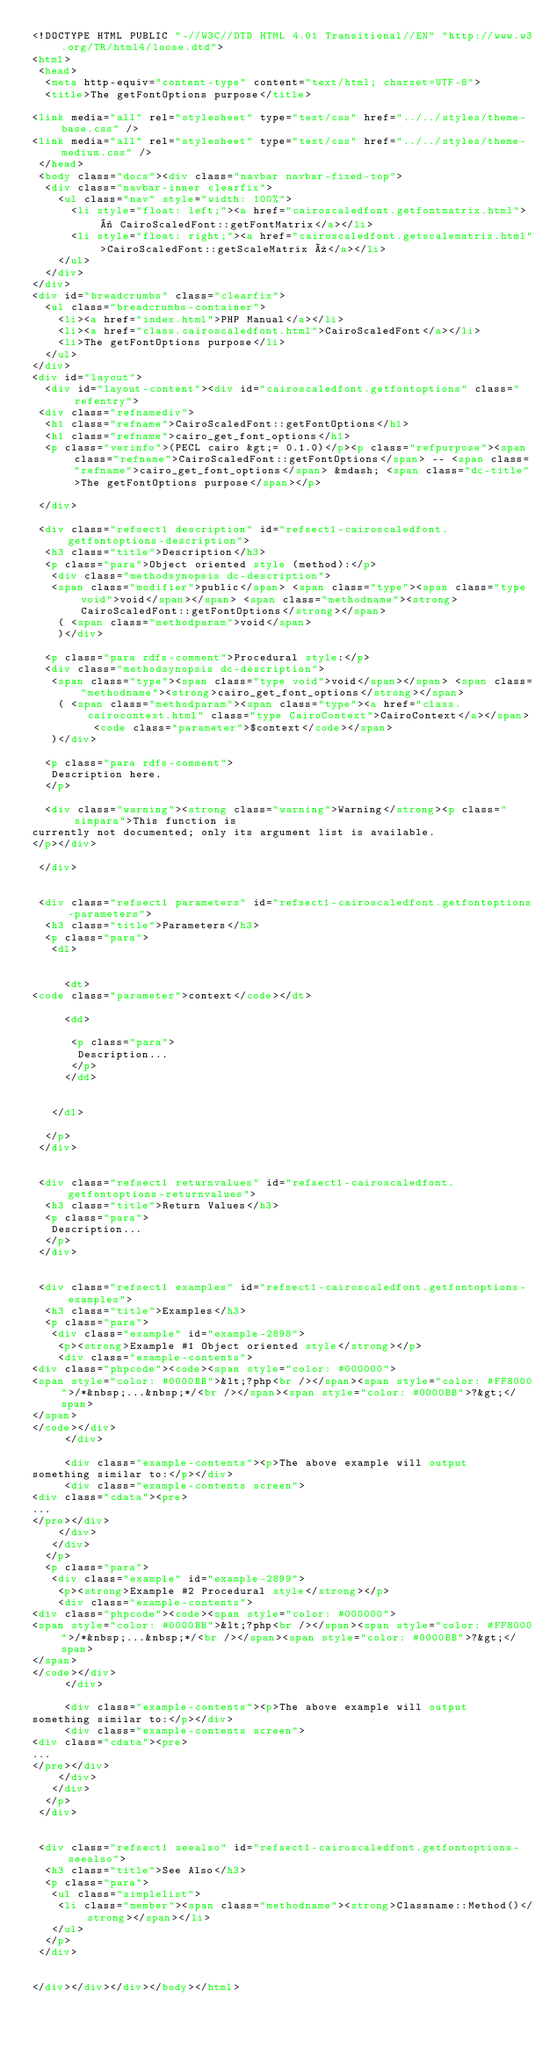<code> <loc_0><loc_0><loc_500><loc_500><_HTML_><!DOCTYPE HTML PUBLIC "-//W3C//DTD HTML 4.01 Transitional//EN" "http://www.w3.org/TR/html4/loose.dtd">
<html>
 <head>
  <meta http-equiv="content-type" content="text/html; charset=UTF-8">
  <title>The getFontOptions purpose</title>

<link media="all" rel="stylesheet" type="text/css" href="../../styles/theme-base.css" />
<link media="all" rel="stylesheet" type="text/css" href="../../styles/theme-medium.css" />
 </head>
 <body class="docs"><div class="navbar navbar-fixed-top">
  <div class="navbar-inner clearfix">
    <ul class="nav" style="width: 100%">
      <li style="float: left;"><a href="cairoscaledfont.getfontmatrix.html">« CairoScaledFont::getFontMatrix</a></li>
      <li style="float: right;"><a href="cairoscaledfont.getscalematrix.html">CairoScaledFont::getScaleMatrix »</a></li>
    </ul>
  </div>
</div>
<div id="breadcrumbs" class="clearfix">
  <ul class="breadcrumbs-container">
    <li><a href="index.html">PHP Manual</a></li>
    <li><a href="class.cairoscaledfont.html">CairoScaledFont</a></li>
    <li>The getFontOptions purpose</li>
  </ul>
</div>
<div id="layout">
  <div id="layout-content"><div id="cairoscaledfont.getfontoptions" class="refentry">
 <div class="refnamediv">
  <h1 class="refname">CairoScaledFont::getFontOptions</h1>
  <h1 class="refname">cairo_get_font_options</h1>
  <p class="verinfo">(PECL cairo &gt;= 0.1.0)</p><p class="refpurpose"><span class="refname">CairoScaledFont::getFontOptions</span> -- <span class="refname">cairo_get_font_options</span> &mdash; <span class="dc-title">The getFontOptions purpose</span></p>

 </div>

 <div class="refsect1 description" id="refsect1-cairoscaledfont.getfontoptions-description">
  <h3 class="title">Description</h3>
  <p class="para">Object oriented style (method):</p>
   <div class="methodsynopsis dc-description">
   <span class="modifier">public</span> <span class="type"><span class="type void">void</span></span> <span class="methodname"><strong>CairoScaledFont::getFontOptions</strong></span>
    ( <span class="methodparam">void</span>
    )</div>

  <p class="para rdfs-comment">Procedural style:</p>
  <div class="methodsynopsis dc-description">
   <span class="type"><span class="type void">void</span></span> <span class="methodname"><strong>cairo_get_font_options</strong></span>
    ( <span class="methodparam"><span class="type"><a href="class.cairocontext.html" class="type CairoContext">CairoContext</a></span> <code class="parameter">$context</code></span>
   )</div>

  <p class="para rdfs-comment">
   Description here.
  </p>
  
  <div class="warning"><strong class="warning">Warning</strong><p class="simpara">This function is
currently not documented; only its argument list is available.
</p></div>
 
 </div>


 <div class="refsect1 parameters" id="refsect1-cairoscaledfont.getfontoptions-parameters">
  <h3 class="title">Parameters</h3>
  <p class="para">
   <dl>

    
     <dt>
<code class="parameter">context</code></dt>

     <dd>

      <p class="para">
       Description...
      </p>
     </dd>

    
   </dl>

  </p>
 </div>


 <div class="refsect1 returnvalues" id="refsect1-cairoscaledfont.getfontoptions-returnvalues">
  <h3 class="title">Return Values</h3>
  <p class="para">
   Description...
  </p>
 </div>


 <div class="refsect1 examples" id="refsect1-cairoscaledfont.getfontoptions-examples">
  <h3 class="title">Examples</h3>
  <p class="para">
   <div class="example" id="example-2898">
    <p><strong>Example #1 Object oriented style</strong></p>
    <div class="example-contents">
<div class="phpcode"><code><span style="color: #000000">
<span style="color: #0000BB">&lt;?php<br /></span><span style="color: #FF8000">/*&nbsp;...&nbsp;*/<br /></span><span style="color: #0000BB">?&gt;</span>
</span>
</code></div>
     </div>

     <div class="example-contents"><p>The above example will output
something similar to:</p></div>
     <div class="example-contents screen">
<div class="cdata"><pre>
...
</pre></div>
    </div>
   </div>
  </p>
  <p class="para">
   <div class="example" id="example-2899">
    <p><strong>Example #2 Procedural style</strong></p>
    <div class="example-contents">
<div class="phpcode"><code><span style="color: #000000">
<span style="color: #0000BB">&lt;?php<br /></span><span style="color: #FF8000">/*&nbsp;...&nbsp;*/<br /></span><span style="color: #0000BB">?&gt;</span>
</span>
</code></div>
     </div>

     <div class="example-contents"><p>The above example will output
something similar to:</p></div>
     <div class="example-contents screen">
<div class="cdata"><pre>
...
</pre></div>
    </div>
   </div>
  </p>
 </div>


 <div class="refsect1 seealso" id="refsect1-cairoscaledfont.getfontoptions-seealso">
  <h3 class="title">See Also</h3>
  <p class="para">
   <ul class="simplelist">
    <li class="member"><span class="methodname"><strong>Classname::Method()</strong></span></li>
   </ul>
  </p>
 </div>


</div></div></div></body></html></code> 